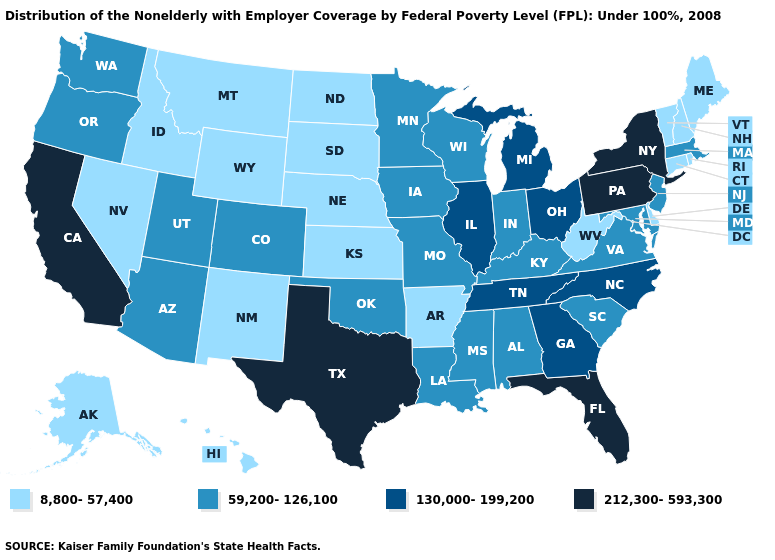Name the states that have a value in the range 212,300-593,300?
Quick response, please. California, Florida, New York, Pennsylvania, Texas. What is the value of Rhode Island?
Give a very brief answer. 8,800-57,400. What is the highest value in the USA?
Concise answer only. 212,300-593,300. Name the states that have a value in the range 212,300-593,300?
Concise answer only. California, Florida, New York, Pennsylvania, Texas. Among the states that border West Virginia , does Pennsylvania have the highest value?
Give a very brief answer. Yes. What is the value of Mississippi?
Short answer required. 59,200-126,100. Does Montana have the highest value in the USA?
Write a very short answer. No. What is the value of Alabama?
Answer briefly. 59,200-126,100. Among the states that border Virginia , does Maryland have the lowest value?
Concise answer only. No. Among the states that border North Dakota , which have the highest value?
Keep it brief. Minnesota. Does Idaho have the lowest value in the West?
Answer briefly. Yes. Which states have the lowest value in the West?
Keep it brief. Alaska, Hawaii, Idaho, Montana, Nevada, New Mexico, Wyoming. Is the legend a continuous bar?
Quick response, please. No. Does Vermont have a lower value than New Mexico?
Write a very short answer. No. 